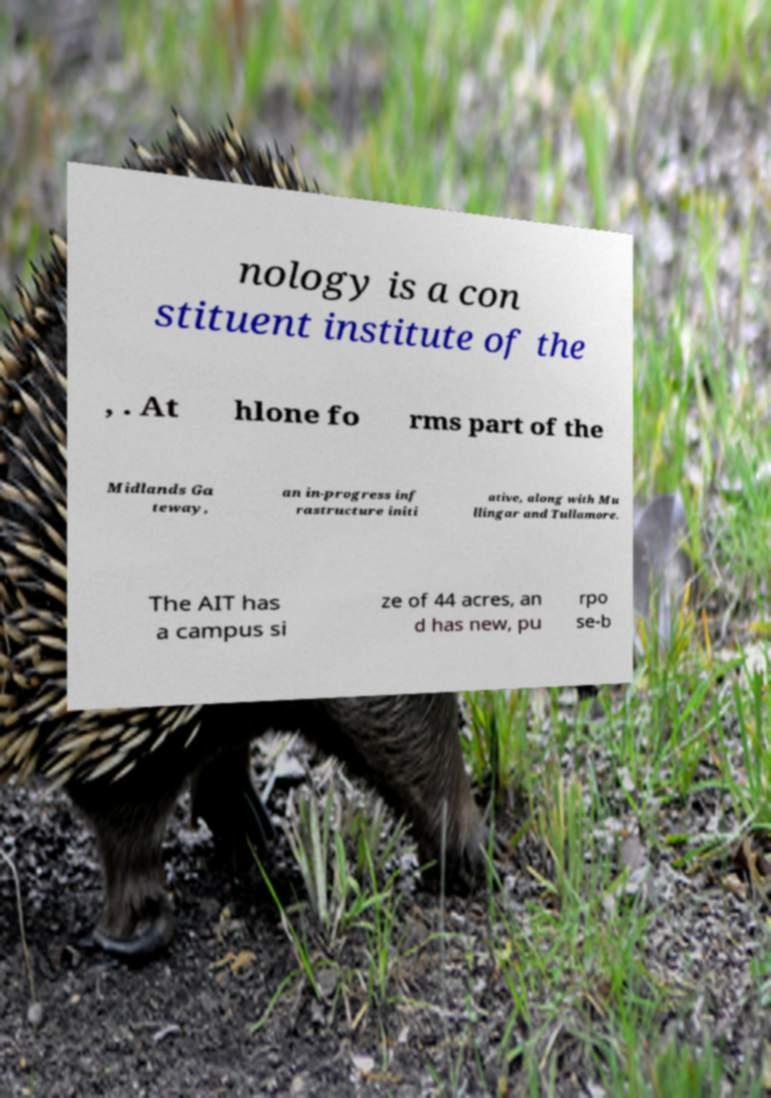Could you extract and type out the text from this image? nology is a con stituent institute of the , . At hlone fo rms part of the Midlands Ga teway, an in-progress inf rastructure initi ative, along with Mu llingar and Tullamore. The AIT has a campus si ze of 44 acres, an d has new, pu rpo se-b 